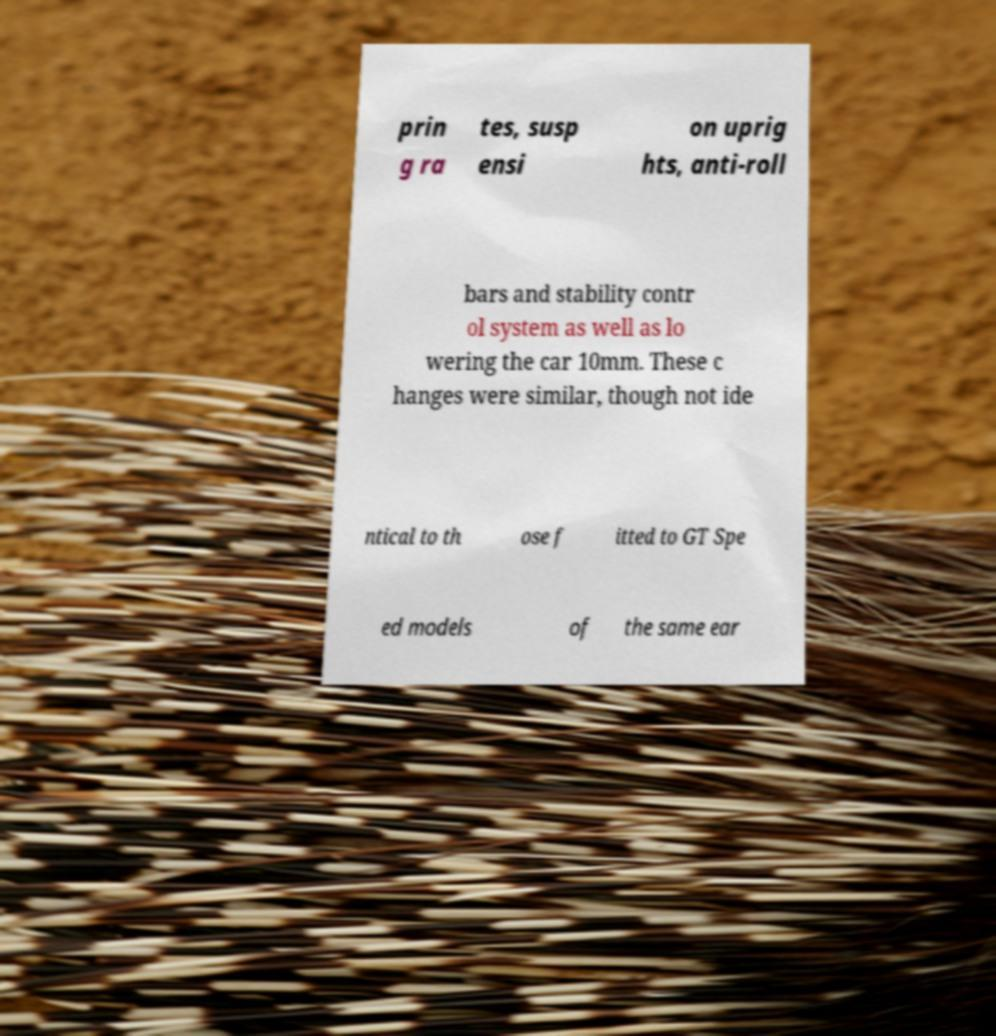For documentation purposes, I need the text within this image transcribed. Could you provide that? prin g ra tes, susp ensi on uprig hts, anti-roll bars and stability contr ol system as well as lo wering the car 10mm. These c hanges were similar, though not ide ntical to th ose f itted to GT Spe ed models of the same ear 